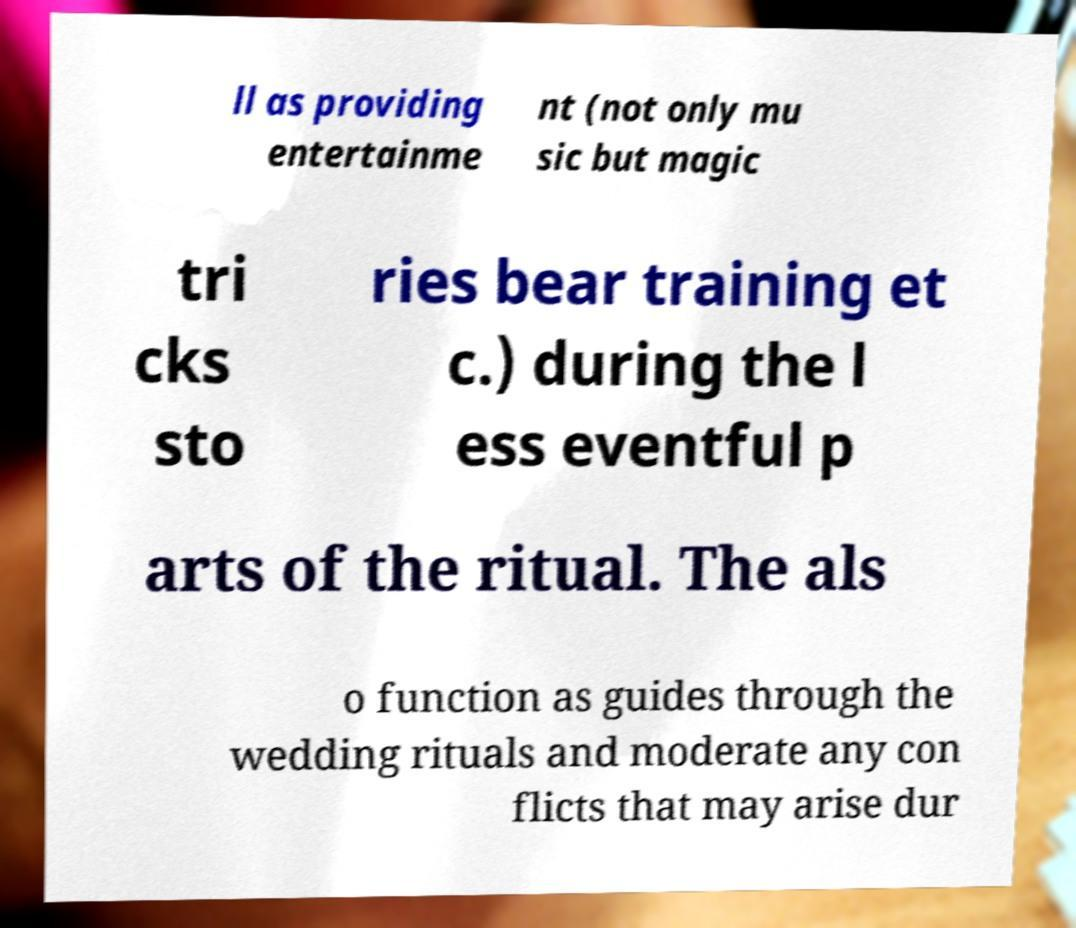What messages or text are displayed in this image? I need them in a readable, typed format. ll as providing entertainme nt (not only mu sic but magic tri cks sto ries bear training et c.) during the l ess eventful p arts of the ritual. The als o function as guides through the wedding rituals and moderate any con flicts that may arise dur 